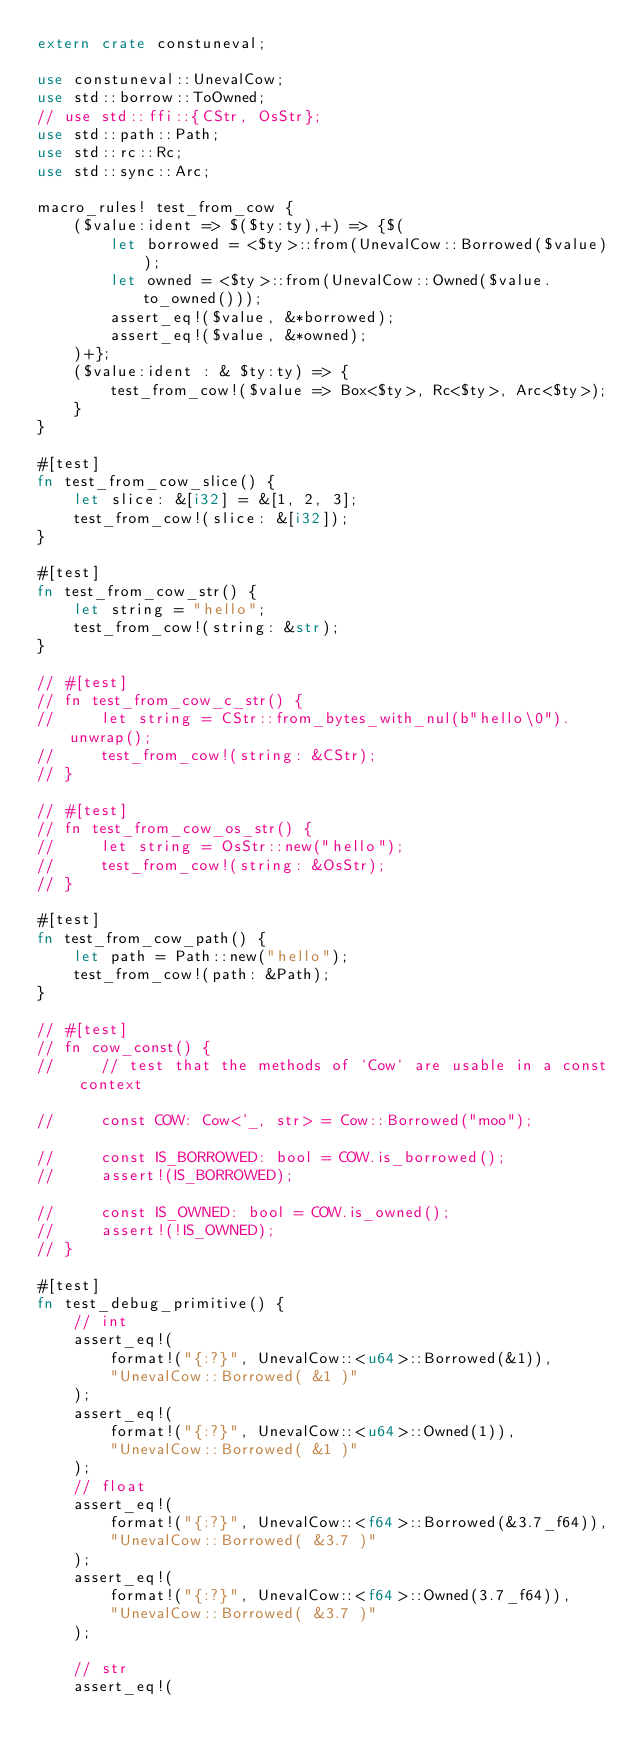Convert code to text. <code><loc_0><loc_0><loc_500><loc_500><_Rust_>extern crate constuneval;

use constuneval::UnevalCow;
use std::borrow::ToOwned;
// use std::ffi::{CStr, OsStr};
use std::path::Path;
use std::rc::Rc;
use std::sync::Arc;

macro_rules! test_from_cow {
    ($value:ident => $($ty:ty),+) => {$(
        let borrowed = <$ty>::from(UnevalCow::Borrowed($value));
        let owned = <$ty>::from(UnevalCow::Owned($value.to_owned()));
        assert_eq!($value, &*borrowed);
        assert_eq!($value, &*owned);
    )+};
    ($value:ident : & $ty:ty) => {
        test_from_cow!($value => Box<$ty>, Rc<$ty>, Arc<$ty>);
    }
}

#[test]
fn test_from_cow_slice() {
    let slice: &[i32] = &[1, 2, 3];
    test_from_cow!(slice: &[i32]);
}

#[test]
fn test_from_cow_str() {
    let string = "hello";
    test_from_cow!(string: &str);
}

// #[test]
// fn test_from_cow_c_str() {
//     let string = CStr::from_bytes_with_nul(b"hello\0").unwrap();
//     test_from_cow!(string: &CStr);
// }

// #[test]
// fn test_from_cow_os_str() {
//     let string = OsStr::new("hello");
//     test_from_cow!(string: &OsStr);
// }

#[test]
fn test_from_cow_path() {
    let path = Path::new("hello");
    test_from_cow!(path: &Path);
}

// #[test]
// fn cow_const() {
//     // test that the methods of `Cow` are usable in a const context

//     const COW: Cow<'_, str> = Cow::Borrowed("moo");

//     const IS_BORROWED: bool = COW.is_borrowed();
//     assert!(IS_BORROWED);

//     const IS_OWNED: bool = COW.is_owned();
//     assert!(!IS_OWNED);
// }

#[test]
fn test_debug_primitive() {
    // int
    assert_eq!(
        format!("{:?}", UnevalCow::<u64>::Borrowed(&1)),
        "UnevalCow::Borrowed( &1 )"
    );
    assert_eq!(
        format!("{:?}", UnevalCow::<u64>::Owned(1)),
        "UnevalCow::Borrowed( &1 )"
    );
    // float
    assert_eq!(
        format!("{:?}", UnevalCow::<f64>::Borrowed(&3.7_f64)),
        "UnevalCow::Borrowed( &3.7 )"
    );
    assert_eq!(
        format!("{:?}", UnevalCow::<f64>::Owned(3.7_f64)),
        "UnevalCow::Borrowed( &3.7 )"
    );

    // str
    assert_eq!(</code> 